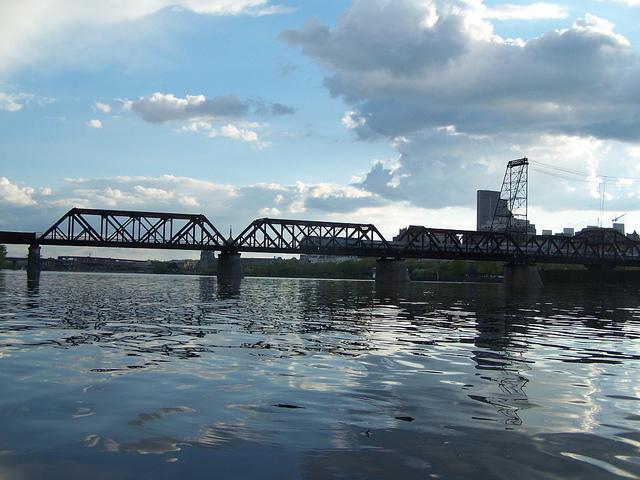How many purple ties are there?
Give a very brief answer. 0. 